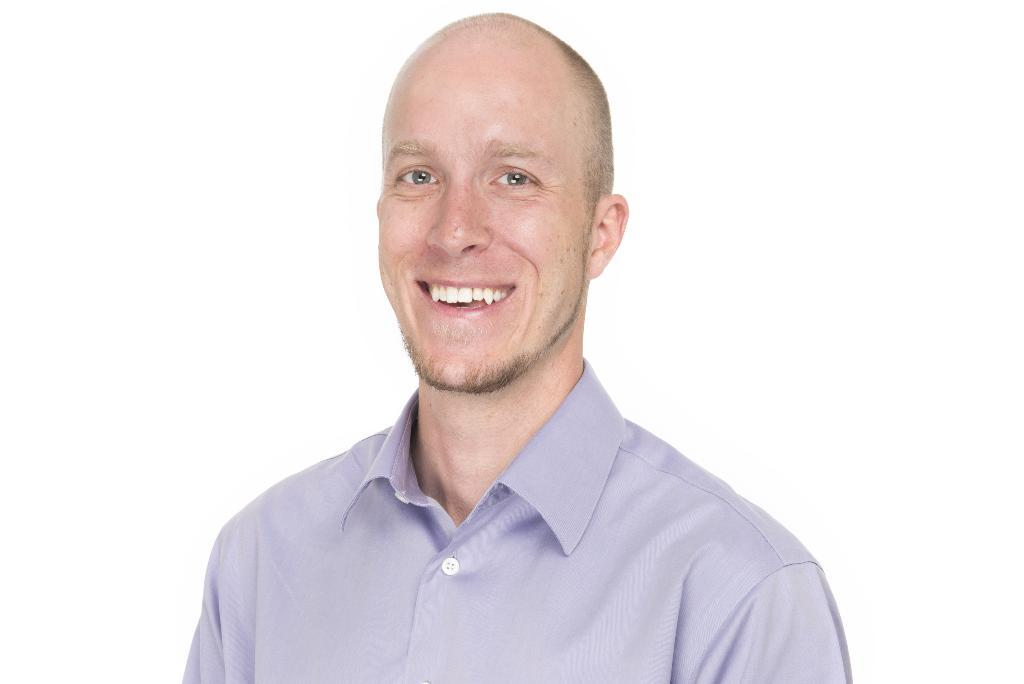Who is present in the image? There is a man in the image. What is the man doing in the image? The man is smiling in the image. What is the man wearing in the image? The man is wearing a shirt in the image. What is the color of the background in the image? The background of the image is white. Is the man sinking in quicksand in the image? There is no quicksand present in the image, so the man is not sinking in it. What type of shoes is the man wearing in the image? The provided facts do not mention shoes, so we cannot determine the type of shoes the man is wearing in the image. 